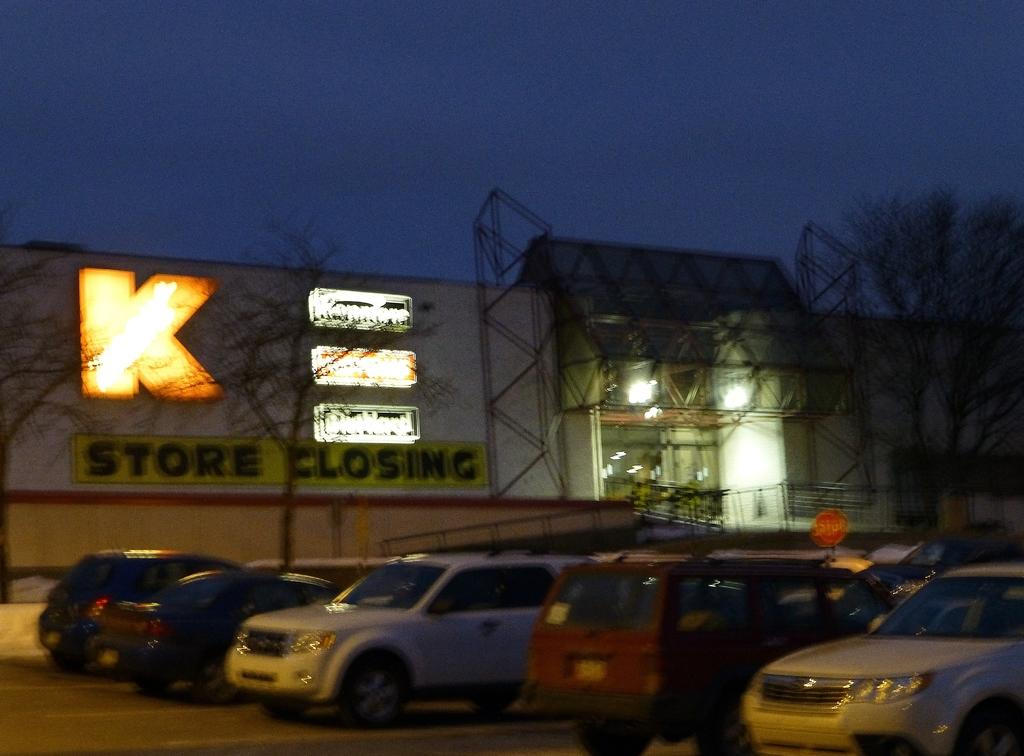<image>
Describe the image concisely. Several differently colored vehicles in a parking lot with a store with a giant K logo on it. 